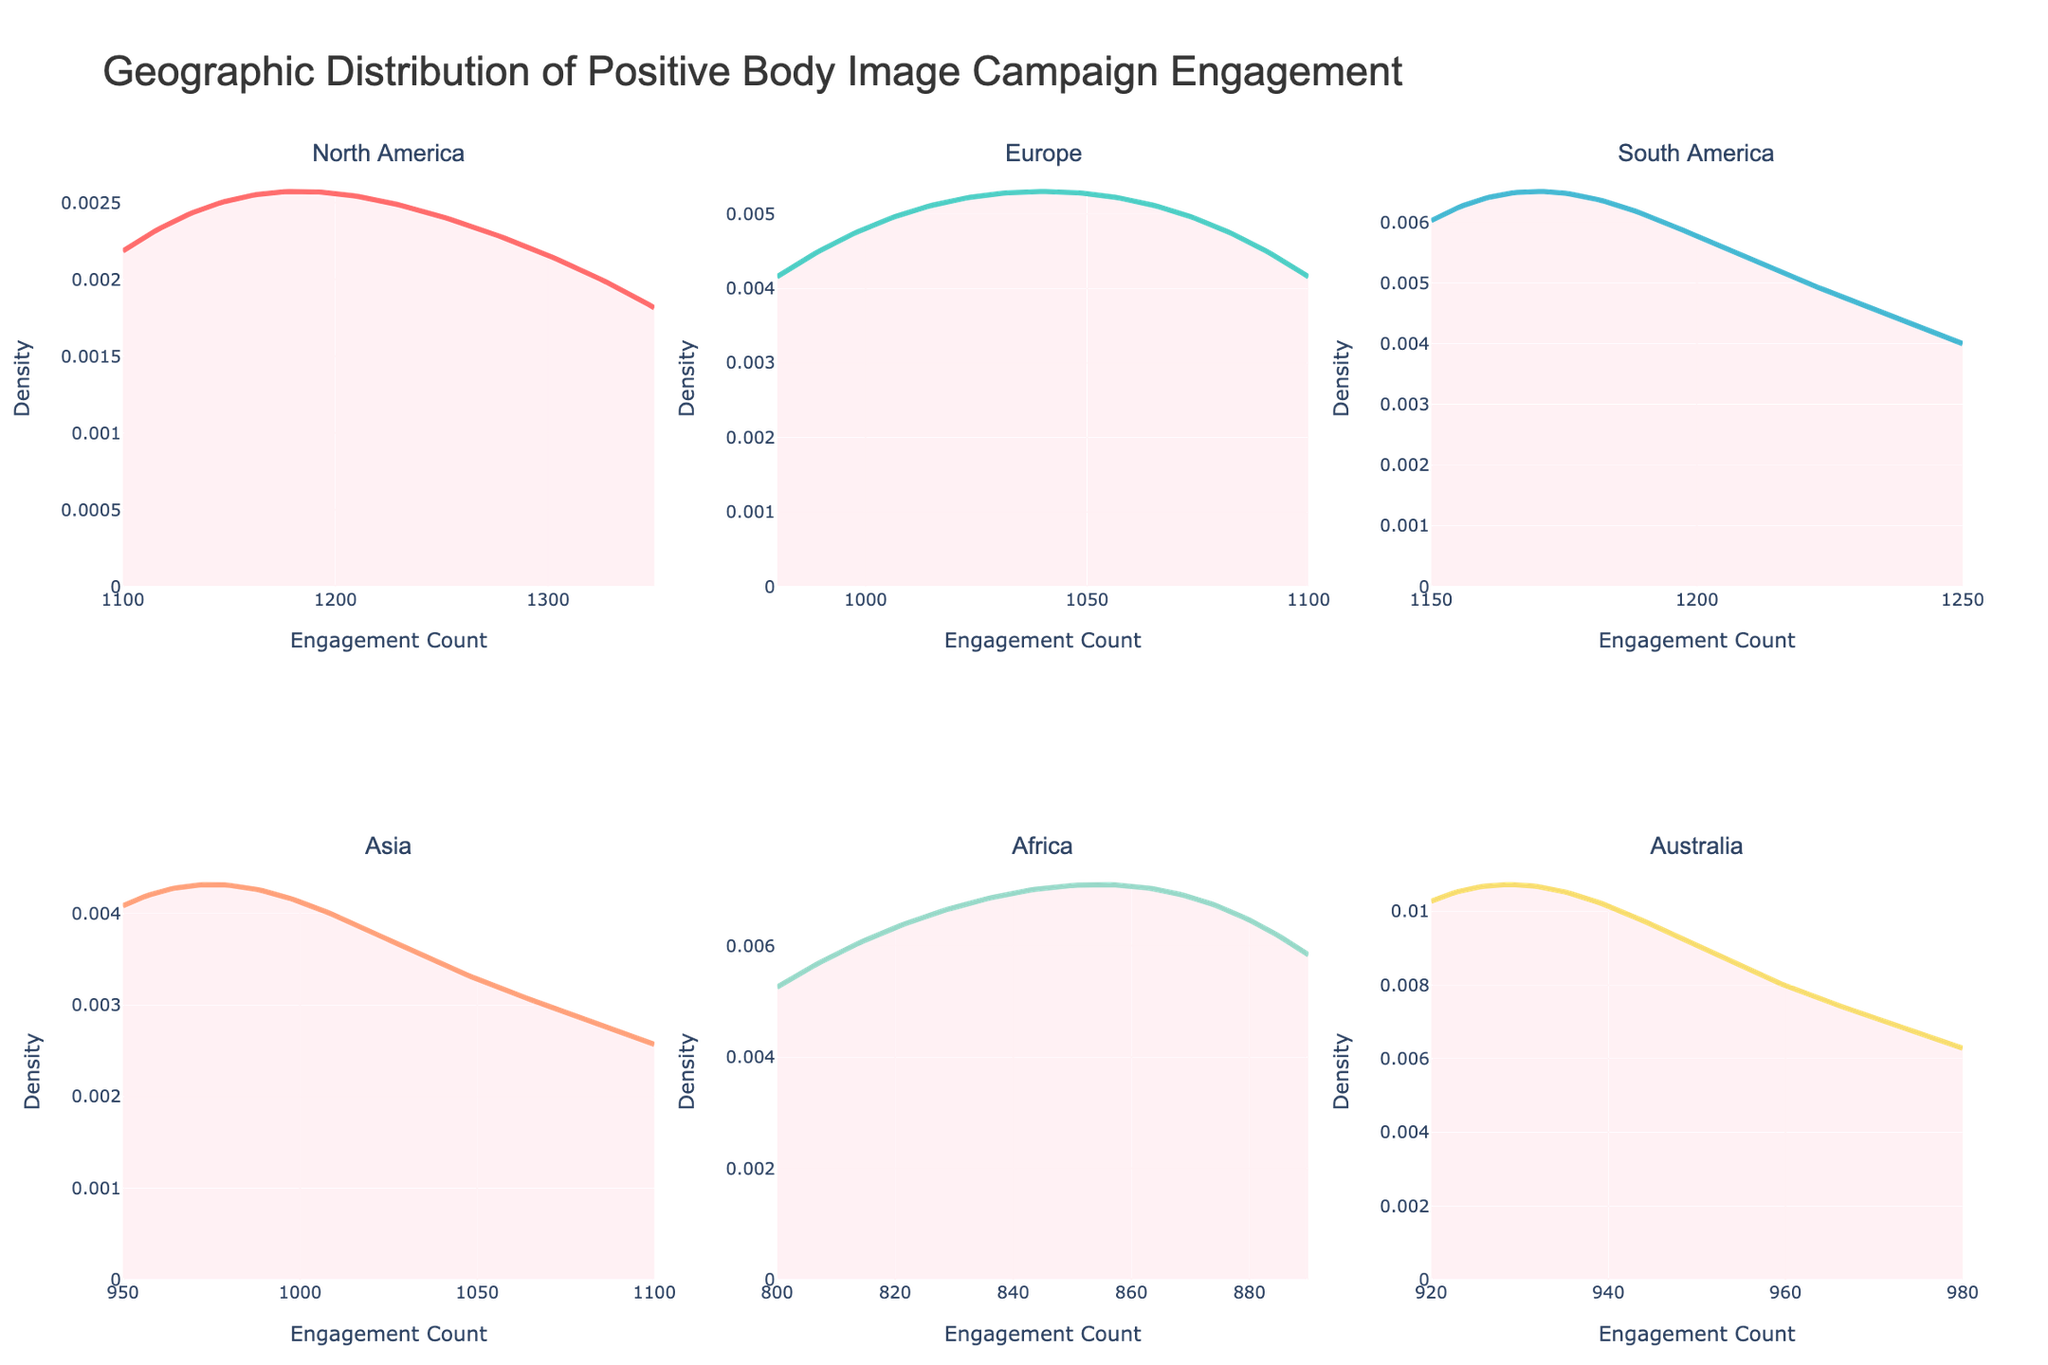What's the title of the figure? The title is usually prominently displayed at the top of the figure. In this case, it reads "Geographic Distribution of Positive Body Image Campaign Engagement".
Answer: Geographic Distribution of Positive Body Image Campaign Engagement How many regions are shown in the figure? By counting each subplot’s title, you can see there are six regions listed across the two rows and three columns.
Answer: Six Which region has the highest peak density in its distribution? To find this, look for the region with the highest peak on its density plot. North America's density plot appears to have the highest peak.
Answer: North America In which region is the engagement count the most evenly distributed? An evenly distributed engagement count would have a relatively lower and broader peak. Europe's and Australia’s density plots look more evenly spread out compared to others.
Answer: Europe and Australia Between North America and Africa, which region shows a wider spread of engagement counts? The spread of engagement counts can be determined by examining the width of the density plot band from the lowest to highest values. Africa shows a wider band compared to North America, indicating a wider spread.
Answer: Africa Which regions have engagement counts that overlap around the count of 1100? Look at the x-axis of each subplot and observe where the density plots overlap. North America, South America, and Asia all show density around the 1100 mark.
Answer: North America, South America, Asia What is the approximate engagement count range for Europe? By examining the x-axis of the Europe subplot, the engagement counts range approximately from 980 to 1100.
Answer: 980 to 1100 Comparing South America and Australia, which region has a higher average engagement count? The peak and spread of density can give a sense of average engagement counts. South America's density is centered around higher values than Australia’s, indicating a higher average engagement.
Answer: South America In the subplot for Asia, what is the engagement count at which the density is highest? Observing the peak of the density curve in Asia's subplot, you find it near the engagement count of 1000.
Answer: 1000 Do any regions show multiple peaks in their engagement distributions? Check each subplot for multiple peaks in the density curve. The plots generally show single peaks, with none demonstrating clear multiple peaks.
Answer: No 